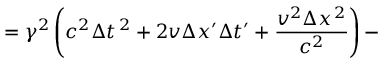<formula> <loc_0><loc_0><loc_500><loc_500>= \gamma ^ { 2 } \left ( c ^ { 2 } \Delta t ^ { \, 2 } + 2 v \Delta x ^ { \prime } \Delta t ^ { \prime } + { \frac { v ^ { 2 } \Delta x ^ { \, 2 } } { c ^ { 2 } } } \right ) -</formula> 